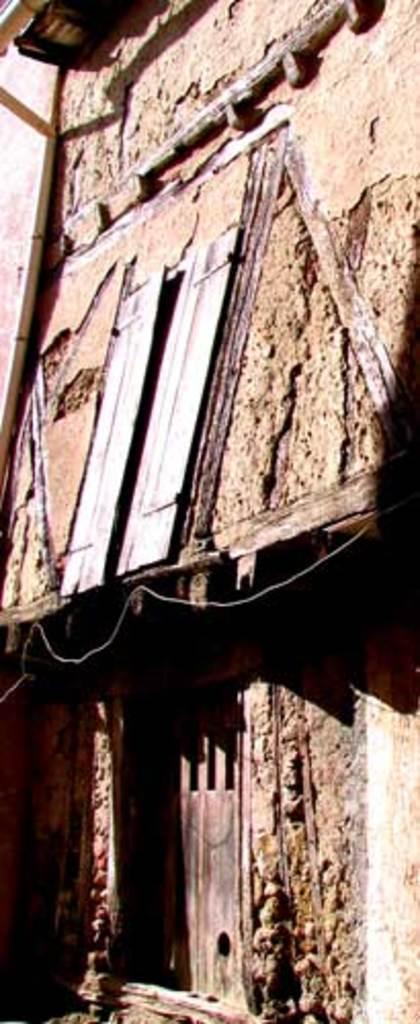Can you describe this image briefly? In this image we can see a house with window and door. 